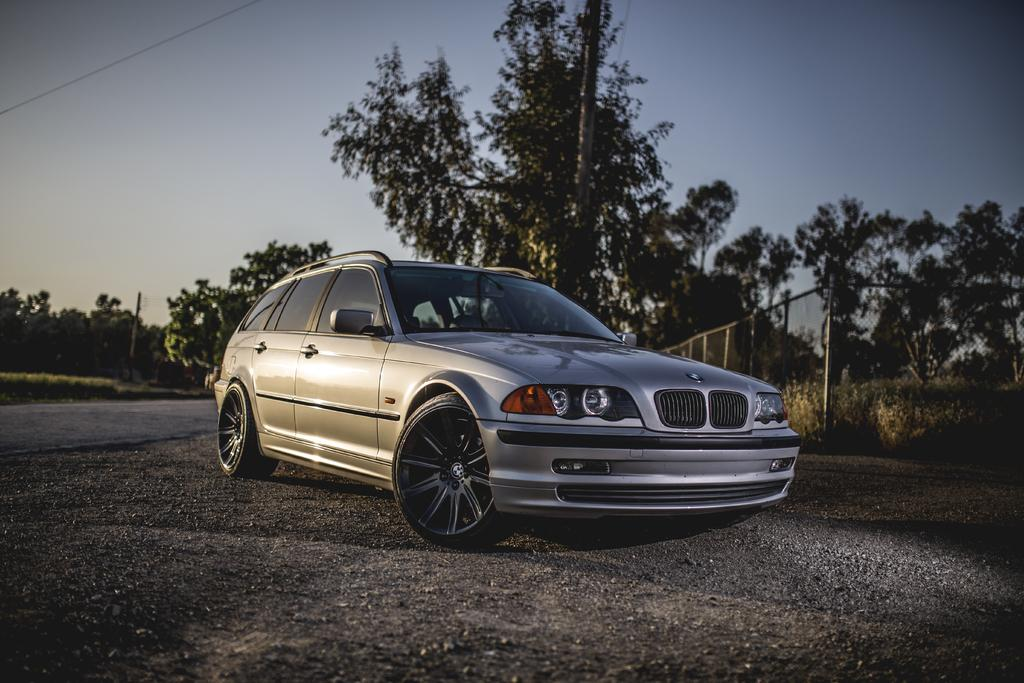What is located on the ground in the image? There is a vehicle on the ground in the image. What type of natural elements can be seen in the image? There are trees and plants in the image. What man-made structures are present in the image? There are poles and a fence in the image. What can be seen in the background of the image? The sky is visible in the background of the image. How does the frog sleep on the vehicle in the image? There is no frog present in the image, so it cannot be sleeping on the vehicle. 